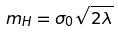<formula> <loc_0><loc_0><loc_500><loc_500>m _ { H } = \sigma _ { 0 } \sqrt { 2 \lambda }</formula> 